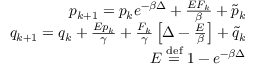<formula> <loc_0><loc_0><loc_500><loc_500>\begin{array} { r } { p _ { k + 1 } = p _ { k } e ^ { - \beta \Delta } + \frac { E F _ { k } } { \beta } + \tilde { p } _ { k } } \\ { q _ { k + 1 } = q _ { k } + \frac { E p _ { k } } { \gamma } + \frac { F _ { k } } { \gamma } \left [ \Delta - \frac { E } { \beta } \right ] + \tilde { q } _ { k } } \\ { E \stackrel { d e f } { = } 1 - e ^ { - \beta \Delta } } \end{array}</formula> 